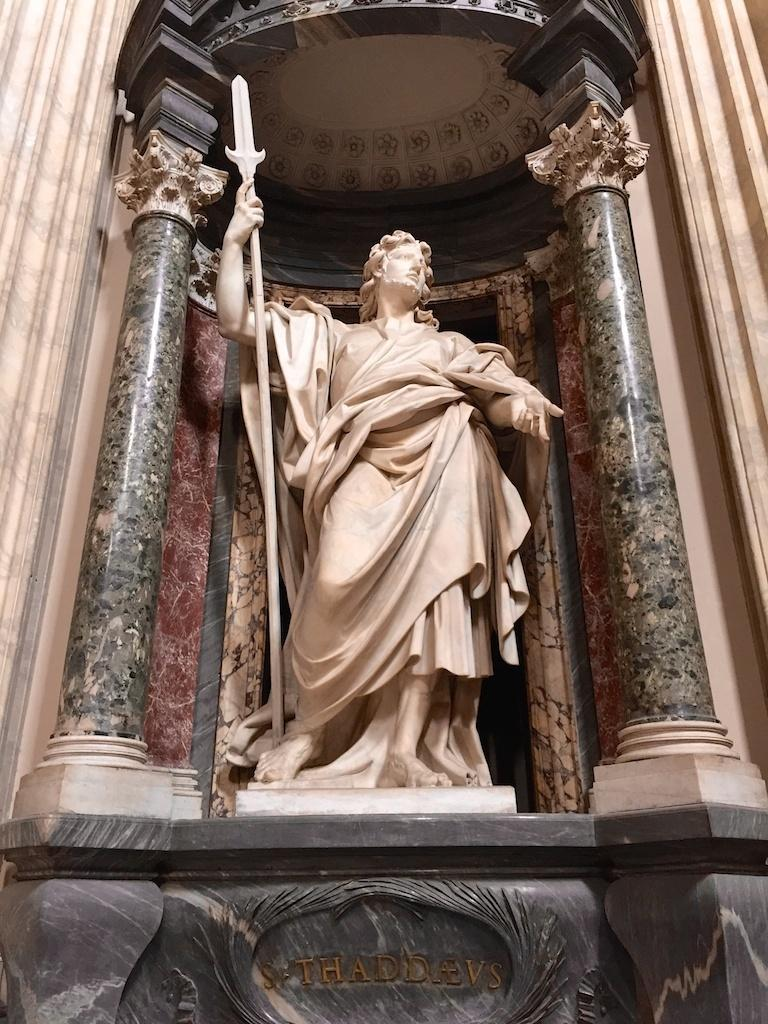What is the main subject of the image? The main subject of the image is a sculpture. Can you describe any additional features of the sculpture? Yes, there is text written on the sculpture. How many grapes are on the hill next to the sculpture in the image? There are no grapes or hills present in the image; it only features a sculpture with text. 